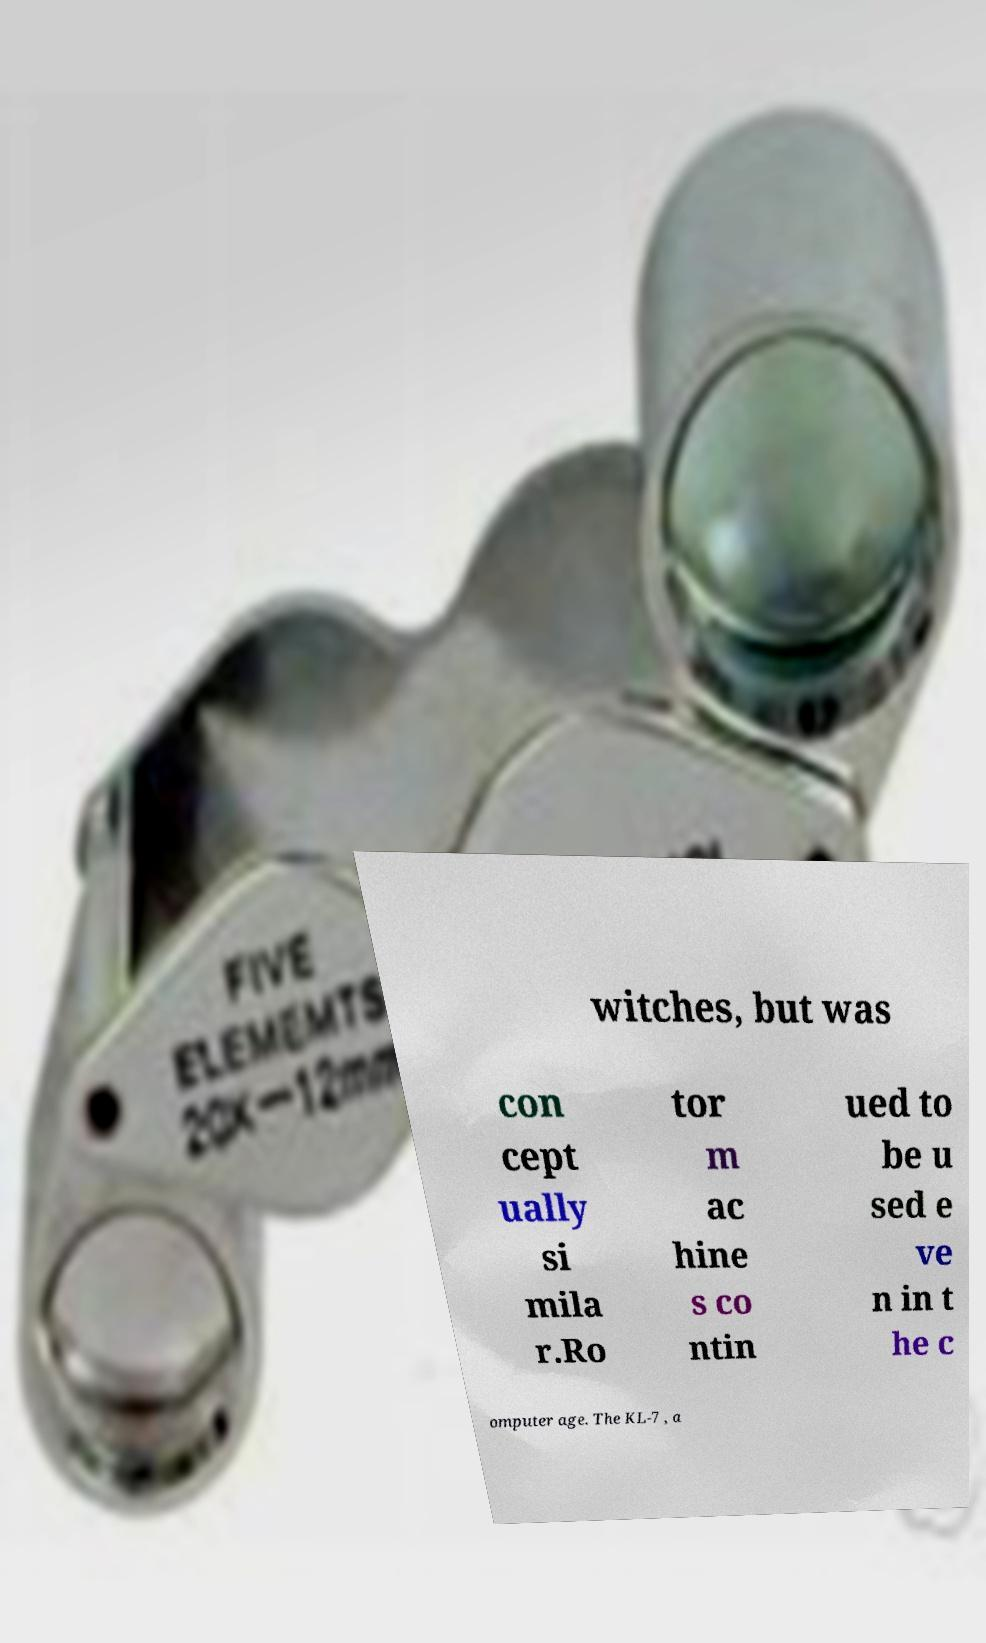Could you extract and type out the text from this image? witches, but was con cept ually si mila r.Ro tor m ac hine s co ntin ued to be u sed e ve n in t he c omputer age. The KL-7 , a 